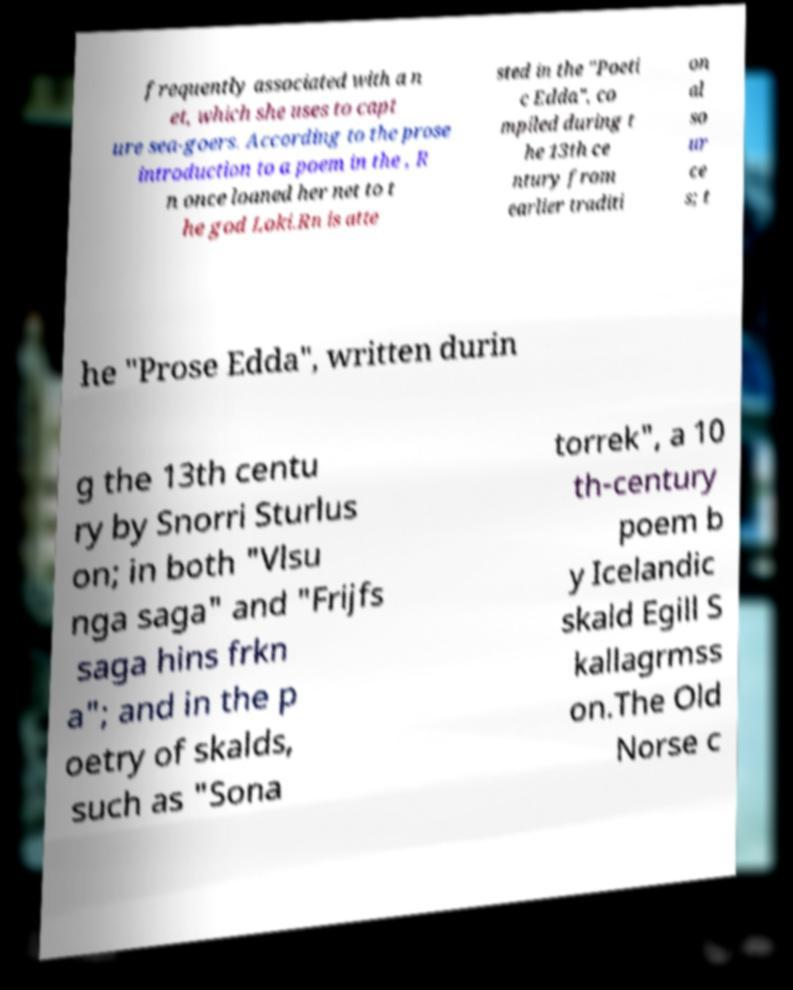Could you extract and type out the text from this image? frequently associated with a n et, which she uses to capt ure sea-goers. According to the prose introduction to a poem in the , R n once loaned her net to t he god Loki.Rn is atte sted in the "Poeti c Edda", co mpiled during t he 13th ce ntury from earlier traditi on al so ur ce s; t he "Prose Edda", written durin g the 13th centu ry by Snorri Sturlus on; in both "Vlsu nga saga" and "Frijfs saga hins frkn a"; and in the p oetry of skalds, such as "Sona torrek", a 10 th-century poem b y Icelandic skald Egill S kallagrmss on.The Old Norse c 